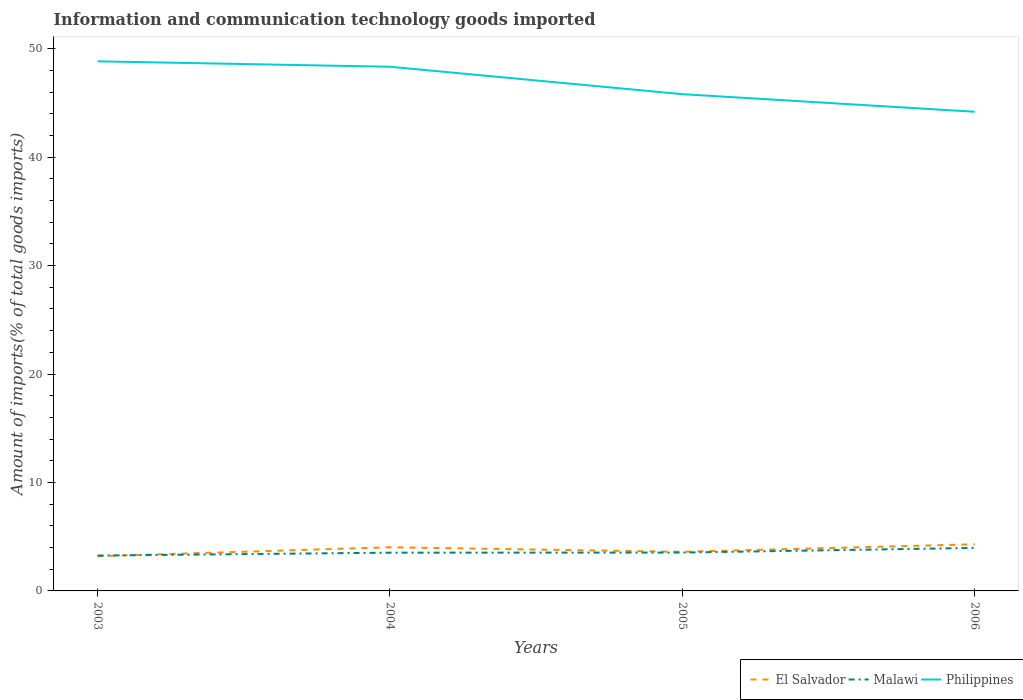Across all years, what is the maximum amount of goods imported in El Salvador?
Make the answer very short. 3.2. In which year was the amount of goods imported in Malawi maximum?
Offer a terse response. 2003. What is the total amount of goods imported in Philippines in the graph?
Keep it short and to the point. 4.65. What is the difference between the highest and the second highest amount of goods imported in Malawi?
Make the answer very short. 0.7. What is the difference between the highest and the lowest amount of goods imported in El Salvador?
Keep it short and to the point. 2. What is the difference between two consecutive major ticks on the Y-axis?
Keep it short and to the point. 10. Does the graph contain any zero values?
Your response must be concise. No. Does the graph contain grids?
Make the answer very short. No. Where does the legend appear in the graph?
Your response must be concise. Bottom right. How many legend labels are there?
Your answer should be very brief. 3. How are the legend labels stacked?
Ensure brevity in your answer.  Horizontal. What is the title of the graph?
Make the answer very short. Information and communication technology goods imported. What is the label or title of the Y-axis?
Make the answer very short. Amount of imports(% of total goods imports). What is the Amount of imports(% of total goods imports) of El Salvador in 2003?
Provide a short and direct response. 3.2. What is the Amount of imports(% of total goods imports) of Malawi in 2003?
Give a very brief answer. 3.26. What is the Amount of imports(% of total goods imports) of Philippines in 2003?
Offer a very short reply. 48.83. What is the Amount of imports(% of total goods imports) in El Salvador in 2004?
Keep it short and to the point. 4.03. What is the Amount of imports(% of total goods imports) in Malawi in 2004?
Your answer should be very brief. 3.53. What is the Amount of imports(% of total goods imports) in Philippines in 2004?
Keep it short and to the point. 48.33. What is the Amount of imports(% of total goods imports) in El Salvador in 2005?
Provide a short and direct response. 3.61. What is the Amount of imports(% of total goods imports) in Malawi in 2005?
Keep it short and to the point. 3.54. What is the Amount of imports(% of total goods imports) of Philippines in 2005?
Keep it short and to the point. 45.81. What is the Amount of imports(% of total goods imports) in El Salvador in 2006?
Provide a short and direct response. 4.3. What is the Amount of imports(% of total goods imports) in Malawi in 2006?
Your answer should be very brief. 3.96. What is the Amount of imports(% of total goods imports) in Philippines in 2006?
Offer a terse response. 44.18. Across all years, what is the maximum Amount of imports(% of total goods imports) of El Salvador?
Your answer should be very brief. 4.3. Across all years, what is the maximum Amount of imports(% of total goods imports) in Malawi?
Your answer should be compact. 3.96. Across all years, what is the maximum Amount of imports(% of total goods imports) in Philippines?
Offer a terse response. 48.83. Across all years, what is the minimum Amount of imports(% of total goods imports) of El Salvador?
Ensure brevity in your answer.  3.2. Across all years, what is the minimum Amount of imports(% of total goods imports) in Malawi?
Your answer should be compact. 3.26. Across all years, what is the minimum Amount of imports(% of total goods imports) of Philippines?
Make the answer very short. 44.18. What is the total Amount of imports(% of total goods imports) of El Salvador in the graph?
Your answer should be compact. 15.13. What is the total Amount of imports(% of total goods imports) of Malawi in the graph?
Your answer should be compact. 14.29. What is the total Amount of imports(% of total goods imports) in Philippines in the graph?
Your answer should be compact. 187.16. What is the difference between the Amount of imports(% of total goods imports) in El Salvador in 2003 and that in 2004?
Your answer should be compact. -0.83. What is the difference between the Amount of imports(% of total goods imports) in Malawi in 2003 and that in 2004?
Provide a short and direct response. -0.27. What is the difference between the Amount of imports(% of total goods imports) in Philippines in 2003 and that in 2004?
Give a very brief answer. 0.5. What is the difference between the Amount of imports(% of total goods imports) in El Salvador in 2003 and that in 2005?
Ensure brevity in your answer.  -0.4. What is the difference between the Amount of imports(% of total goods imports) in Malawi in 2003 and that in 2005?
Offer a terse response. -0.28. What is the difference between the Amount of imports(% of total goods imports) in Philippines in 2003 and that in 2005?
Your answer should be compact. 3.03. What is the difference between the Amount of imports(% of total goods imports) in El Salvador in 2003 and that in 2006?
Ensure brevity in your answer.  -1.1. What is the difference between the Amount of imports(% of total goods imports) of Malawi in 2003 and that in 2006?
Your answer should be compact. -0.7. What is the difference between the Amount of imports(% of total goods imports) of Philippines in 2003 and that in 2006?
Offer a very short reply. 4.65. What is the difference between the Amount of imports(% of total goods imports) of El Salvador in 2004 and that in 2005?
Your response must be concise. 0.42. What is the difference between the Amount of imports(% of total goods imports) in Malawi in 2004 and that in 2005?
Make the answer very short. -0.01. What is the difference between the Amount of imports(% of total goods imports) of Philippines in 2004 and that in 2005?
Provide a succinct answer. 2.53. What is the difference between the Amount of imports(% of total goods imports) of El Salvador in 2004 and that in 2006?
Your response must be concise. -0.27. What is the difference between the Amount of imports(% of total goods imports) of Malawi in 2004 and that in 2006?
Your answer should be very brief. -0.44. What is the difference between the Amount of imports(% of total goods imports) in Philippines in 2004 and that in 2006?
Provide a succinct answer. 4.15. What is the difference between the Amount of imports(% of total goods imports) in El Salvador in 2005 and that in 2006?
Provide a short and direct response. -0.69. What is the difference between the Amount of imports(% of total goods imports) of Malawi in 2005 and that in 2006?
Offer a very short reply. -0.43. What is the difference between the Amount of imports(% of total goods imports) in Philippines in 2005 and that in 2006?
Offer a terse response. 1.62. What is the difference between the Amount of imports(% of total goods imports) in El Salvador in 2003 and the Amount of imports(% of total goods imports) in Malawi in 2004?
Give a very brief answer. -0.33. What is the difference between the Amount of imports(% of total goods imports) in El Salvador in 2003 and the Amount of imports(% of total goods imports) in Philippines in 2004?
Ensure brevity in your answer.  -45.13. What is the difference between the Amount of imports(% of total goods imports) in Malawi in 2003 and the Amount of imports(% of total goods imports) in Philippines in 2004?
Make the answer very short. -45.07. What is the difference between the Amount of imports(% of total goods imports) in El Salvador in 2003 and the Amount of imports(% of total goods imports) in Malawi in 2005?
Provide a succinct answer. -0.34. What is the difference between the Amount of imports(% of total goods imports) in El Salvador in 2003 and the Amount of imports(% of total goods imports) in Philippines in 2005?
Ensure brevity in your answer.  -42.6. What is the difference between the Amount of imports(% of total goods imports) in Malawi in 2003 and the Amount of imports(% of total goods imports) in Philippines in 2005?
Your answer should be very brief. -42.55. What is the difference between the Amount of imports(% of total goods imports) of El Salvador in 2003 and the Amount of imports(% of total goods imports) of Malawi in 2006?
Give a very brief answer. -0.76. What is the difference between the Amount of imports(% of total goods imports) of El Salvador in 2003 and the Amount of imports(% of total goods imports) of Philippines in 2006?
Your answer should be compact. -40.98. What is the difference between the Amount of imports(% of total goods imports) in Malawi in 2003 and the Amount of imports(% of total goods imports) in Philippines in 2006?
Your answer should be very brief. -40.92. What is the difference between the Amount of imports(% of total goods imports) in El Salvador in 2004 and the Amount of imports(% of total goods imports) in Malawi in 2005?
Provide a succinct answer. 0.49. What is the difference between the Amount of imports(% of total goods imports) of El Salvador in 2004 and the Amount of imports(% of total goods imports) of Philippines in 2005?
Your answer should be compact. -41.78. What is the difference between the Amount of imports(% of total goods imports) of Malawi in 2004 and the Amount of imports(% of total goods imports) of Philippines in 2005?
Your answer should be very brief. -42.28. What is the difference between the Amount of imports(% of total goods imports) of El Salvador in 2004 and the Amount of imports(% of total goods imports) of Malawi in 2006?
Make the answer very short. 0.06. What is the difference between the Amount of imports(% of total goods imports) of El Salvador in 2004 and the Amount of imports(% of total goods imports) of Philippines in 2006?
Make the answer very short. -40.16. What is the difference between the Amount of imports(% of total goods imports) in Malawi in 2004 and the Amount of imports(% of total goods imports) in Philippines in 2006?
Make the answer very short. -40.66. What is the difference between the Amount of imports(% of total goods imports) of El Salvador in 2005 and the Amount of imports(% of total goods imports) of Malawi in 2006?
Keep it short and to the point. -0.36. What is the difference between the Amount of imports(% of total goods imports) in El Salvador in 2005 and the Amount of imports(% of total goods imports) in Philippines in 2006?
Offer a terse response. -40.58. What is the difference between the Amount of imports(% of total goods imports) in Malawi in 2005 and the Amount of imports(% of total goods imports) in Philippines in 2006?
Your response must be concise. -40.65. What is the average Amount of imports(% of total goods imports) of El Salvador per year?
Make the answer very short. 3.78. What is the average Amount of imports(% of total goods imports) of Malawi per year?
Ensure brevity in your answer.  3.57. What is the average Amount of imports(% of total goods imports) in Philippines per year?
Offer a very short reply. 46.79. In the year 2003, what is the difference between the Amount of imports(% of total goods imports) of El Salvador and Amount of imports(% of total goods imports) of Malawi?
Give a very brief answer. -0.06. In the year 2003, what is the difference between the Amount of imports(% of total goods imports) in El Salvador and Amount of imports(% of total goods imports) in Philippines?
Your answer should be very brief. -45.63. In the year 2003, what is the difference between the Amount of imports(% of total goods imports) in Malawi and Amount of imports(% of total goods imports) in Philippines?
Your answer should be compact. -45.57. In the year 2004, what is the difference between the Amount of imports(% of total goods imports) in El Salvador and Amount of imports(% of total goods imports) in Malawi?
Your response must be concise. 0.5. In the year 2004, what is the difference between the Amount of imports(% of total goods imports) in El Salvador and Amount of imports(% of total goods imports) in Philippines?
Your response must be concise. -44.31. In the year 2004, what is the difference between the Amount of imports(% of total goods imports) in Malawi and Amount of imports(% of total goods imports) in Philippines?
Offer a terse response. -44.81. In the year 2005, what is the difference between the Amount of imports(% of total goods imports) in El Salvador and Amount of imports(% of total goods imports) in Malawi?
Give a very brief answer. 0.07. In the year 2005, what is the difference between the Amount of imports(% of total goods imports) of El Salvador and Amount of imports(% of total goods imports) of Philippines?
Your answer should be very brief. -42.2. In the year 2005, what is the difference between the Amount of imports(% of total goods imports) of Malawi and Amount of imports(% of total goods imports) of Philippines?
Provide a succinct answer. -42.27. In the year 2006, what is the difference between the Amount of imports(% of total goods imports) of El Salvador and Amount of imports(% of total goods imports) of Malawi?
Give a very brief answer. 0.34. In the year 2006, what is the difference between the Amount of imports(% of total goods imports) in El Salvador and Amount of imports(% of total goods imports) in Philippines?
Make the answer very short. -39.88. In the year 2006, what is the difference between the Amount of imports(% of total goods imports) in Malawi and Amount of imports(% of total goods imports) in Philippines?
Offer a terse response. -40.22. What is the ratio of the Amount of imports(% of total goods imports) of El Salvador in 2003 to that in 2004?
Your answer should be compact. 0.8. What is the ratio of the Amount of imports(% of total goods imports) of Malawi in 2003 to that in 2004?
Keep it short and to the point. 0.92. What is the ratio of the Amount of imports(% of total goods imports) in Philippines in 2003 to that in 2004?
Provide a succinct answer. 1.01. What is the ratio of the Amount of imports(% of total goods imports) of El Salvador in 2003 to that in 2005?
Your response must be concise. 0.89. What is the ratio of the Amount of imports(% of total goods imports) in Malawi in 2003 to that in 2005?
Offer a terse response. 0.92. What is the ratio of the Amount of imports(% of total goods imports) of Philippines in 2003 to that in 2005?
Provide a short and direct response. 1.07. What is the ratio of the Amount of imports(% of total goods imports) in El Salvador in 2003 to that in 2006?
Your answer should be very brief. 0.74. What is the ratio of the Amount of imports(% of total goods imports) of Malawi in 2003 to that in 2006?
Keep it short and to the point. 0.82. What is the ratio of the Amount of imports(% of total goods imports) of Philippines in 2003 to that in 2006?
Provide a short and direct response. 1.11. What is the ratio of the Amount of imports(% of total goods imports) in El Salvador in 2004 to that in 2005?
Give a very brief answer. 1.12. What is the ratio of the Amount of imports(% of total goods imports) of Malawi in 2004 to that in 2005?
Make the answer very short. 1. What is the ratio of the Amount of imports(% of total goods imports) in Philippines in 2004 to that in 2005?
Ensure brevity in your answer.  1.06. What is the ratio of the Amount of imports(% of total goods imports) of El Salvador in 2004 to that in 2006?
Give a very brief answer. 0.94. What is the ratio of the Amount of imports(% of total goods imports) of Malawi in 2004 to that in 2006?
Your answer should be very brief. 0.89. What is the ratio of the Amount of imports(% of total goods imports) of Philippines in 2004 to that in 2006?
Keep it short and to the point. 1.09. What is the ratio of the Amount of imports(% of total goods imports) in El Salvador in 2005 to that in 2006?
Provide a succinct answer. 0.84. What is the ratio of the Amount of imports(% of total goods imports) in Malawi in 2005 to that in 2006?
Offer a terse response. 0.89. What is the ratio of the Amount of imports(% of total goods imports) of Philippines in 2005 to that in 2006?
Give a very brief answer. 1.04. What is the difference between the highest and the second highest Amount of imports(% of total goods imports) in El Salvador?
Your response must be concise. 0.27. What is the difference between the highest and the second highest Amount of imports(% of total goods imports) of Malawi?
Make the answer very short. 0.43. What is the difference between the highest and the second highest Amount of imports(% of total goods imports) in Philippines?
Offer a very short reply. 0.5. What is the difference between the highest and the lowest Amount of imports(% of total goods imports) of El Salvador?
Provide a short and direct response. 1.1. What is the difference between the highest and the lowest Amount of imports(% of total goods imports) of Malawi?
Keep it short and to the point. 0.7. What is the difference between the highest and the lowest Amount of imports(% of total goods imports) of Philippines?
Your answer should be very brief. 4.65. 